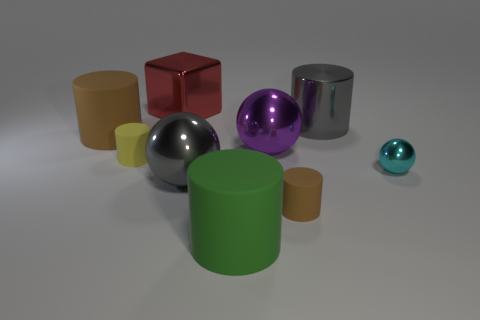Subtract all gray metal balls. How many balls are left? 2 Add 1 large green matte cylinders. How many objects exist? 10 Subtract all cyan balls. How many balls are left? 2 Subtract all cylinders. How many objects are left? 4 Subtract 2 balls. How many balls are left? 1 Add 3 large green matte objects. How many large green matte objects are left? 4 Add 6 tiny red rubber cylinders. How many tiny red rubber cylinders exist? 6 Subtract 1 red blocks. How many objects are left? 8 Subtract all cyan blocks. Subtract all yellow balls. How many blocks are left? 1 Subtract all gray cubes. How many cyan cylinders are left? 0 